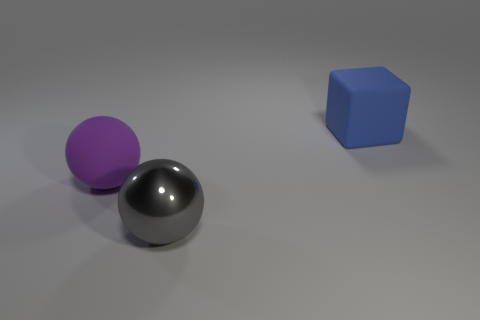Add 2 small gray matte cylinders. How many objects exist? 5 Subtract all spheres. How many objects are left? 1 Subtract 0 green cubes. How many objects are left? 3 Subtract all small cyan cubes. Subtract all large blue rubber objects. How many objects are left? 2 Add 3 metallic balls. How many metallic balls are left? 4 Add 1 gray cubes. How many gray cubes exist? 1 